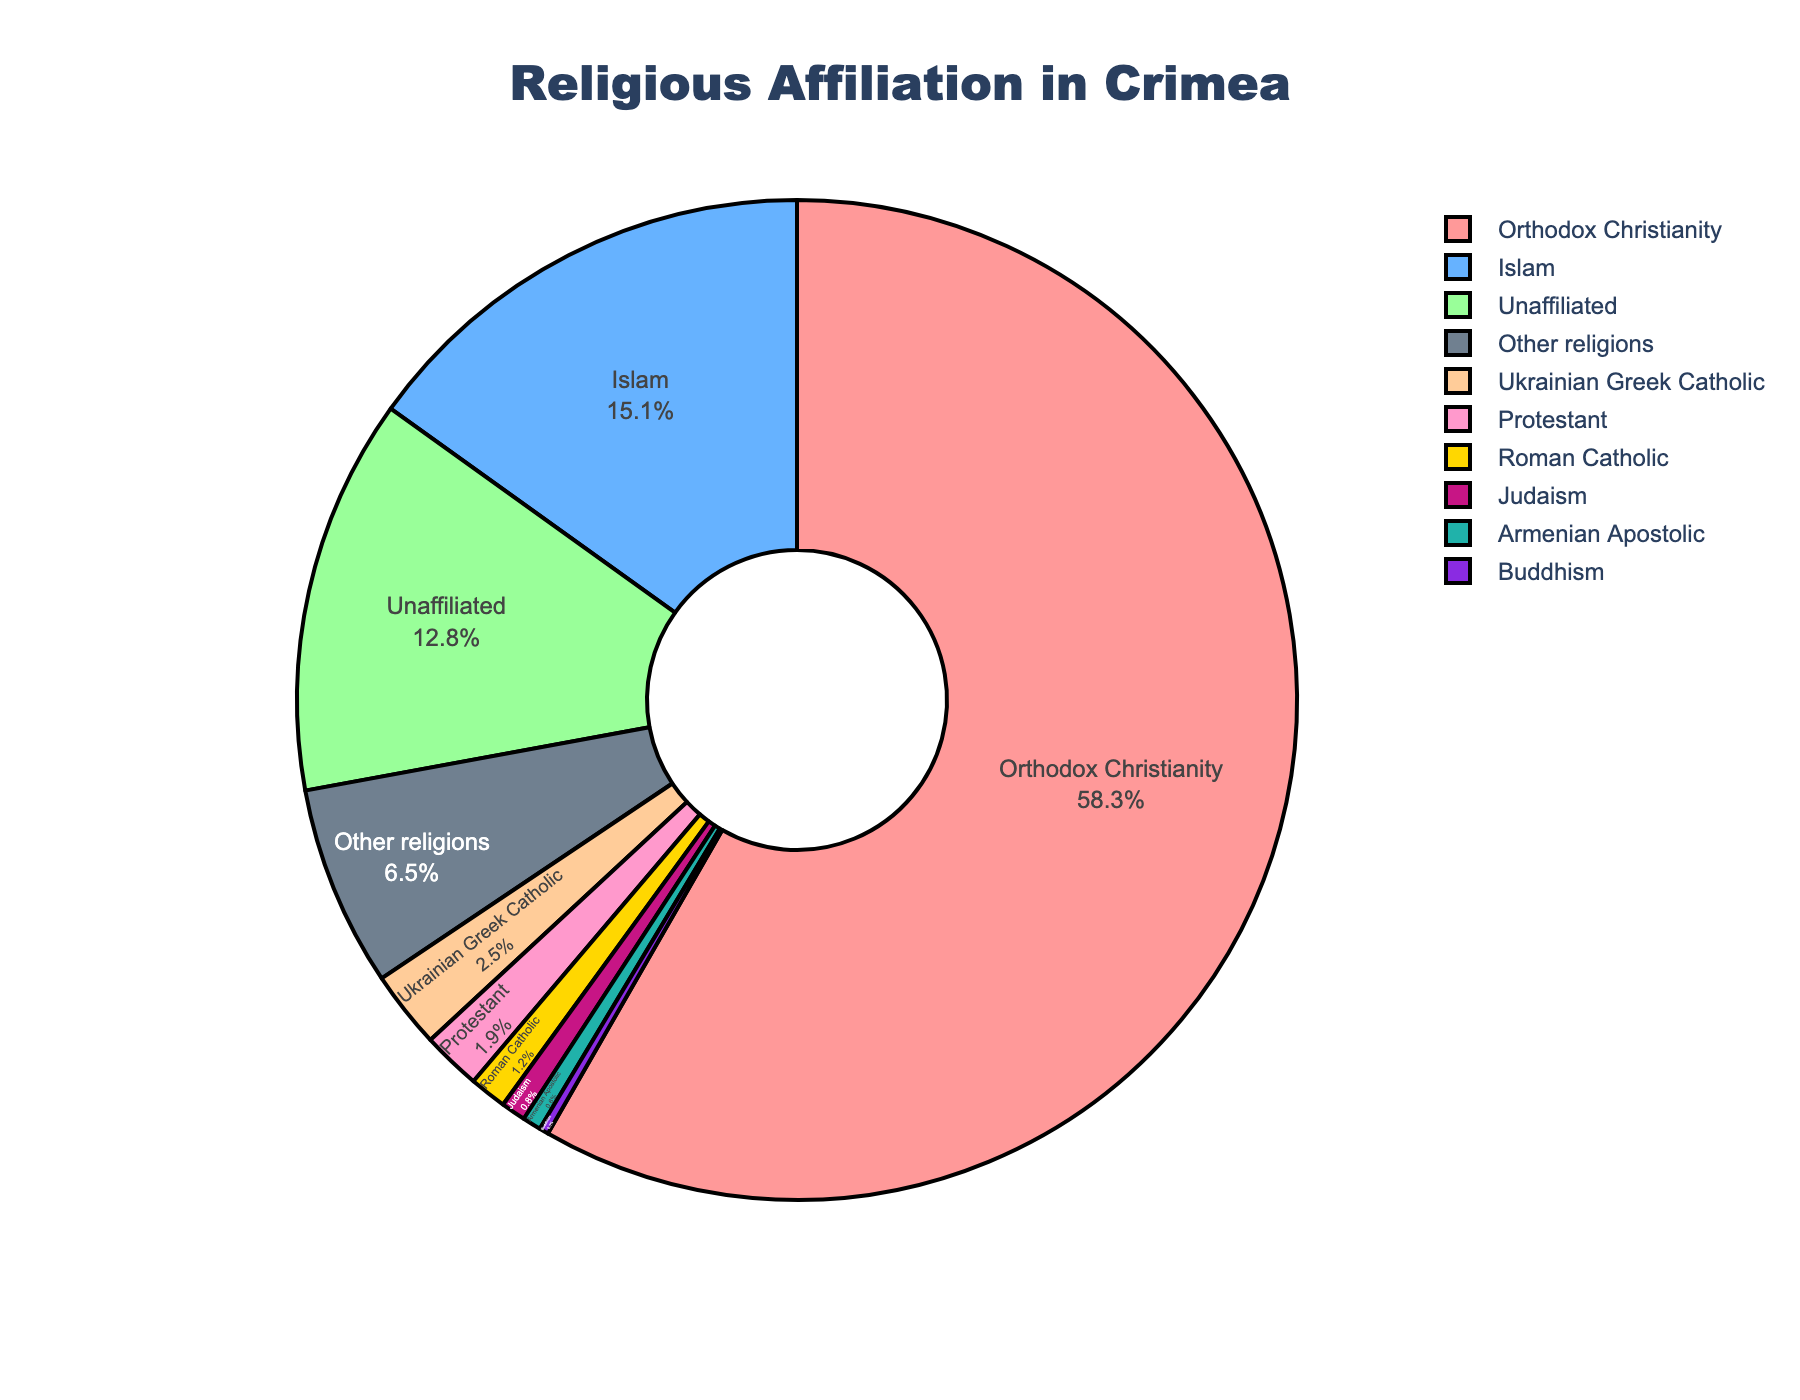what is the most common religion in Crimea? The most sizable section of the pie chart is labeled "Orthodox Christianity," which indicates it is the most common religion.
Answer: Orthodox Christianity Which is the second largest religious group in Crimea based on this chart? The section labeled "Islam" is the second largest in the pie chart, indicating it is the second largest religious group.
Answer: Islam What percentage of people in Crimea follow Protestantism and Roman Catholicism combined? Add the percentage of people following Protestantism (1.9%) and Roman Catholicism (1.2%) together: 1.9% + 1.2% = 3.1%.
Answer: 3.1% Which religions have less than 1% of followers in Crimea? The pie chart shows "Judaism" at 0.8%, "Armenian Apostolic" at 0.6%, and "Buddhism" at 0.3%, all of which are under 1%.
Answer: Judaism, Armenian Apostolic, Buddhism How does the percentage of people unaffiliated with any religion compare to that of Muslims? The percentage of unaffiliated people is 12.8%, whereas the percentage of Muslims is 15.1%. 15.1% is greater than 12.8%.
Answer: The percentage of Muslims is greater What is the total percentage of people following Christianity in Crimea? Sum the percentages of all Christian denominations: Orthodox Christianity (58.3%), Ukrainian Greek Catholic (2.5%), Protestant (1.9%), and Roman Catholic (1.2%). 58.3% + 2.5% + 1.9% + 1.2% = 63.9%.
Answer: 63.9% Which religion is represented by a green color in the pie chart? This information cannot be directly derived from your description as colors are not labeled. However, in the absence of that color coding, typically "Orthodox Christianity" might be in green based on common chart color schemes.
Answer: Cannot conclude from given information Rank the top three religions in Crimea by the number of followers. By size in the pie chart, the ranking is: 1) Orthodox Christianity (58.3%), 2) Islam (15.1%), and 3) Unaffiliated (12.8%).
Answer: 1. Orthodox Christianity, 2. Islam, 3. Unaffiliated Estimate the percentage of people following religions other than Christianity and Islam. Summing the percentages of all non-Christian and non-Islam religions: Unaffiliated (12.8%), Judaism (0.8%), Buddhism (0.3%), and Other religions (6.5%). 12.8% + 0.8% + 0.3% + 6.5% = 20.4%.
Answer: 20.4% Which section of the chart takes up more space: "Unaffiliated" or "Other religions"? From the pie chart, compare the sizes visually; "Unaffiliated" is larger with 12.8% compared to "Other religions" at 6.5%.
Answer: Unaffiliated 